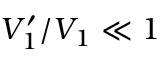<formula> <loc_0><loc_0><loc_500><loc_500>V _ { 1 } ^ { \prime } / V _ { 1 } \ll 1</formula> 